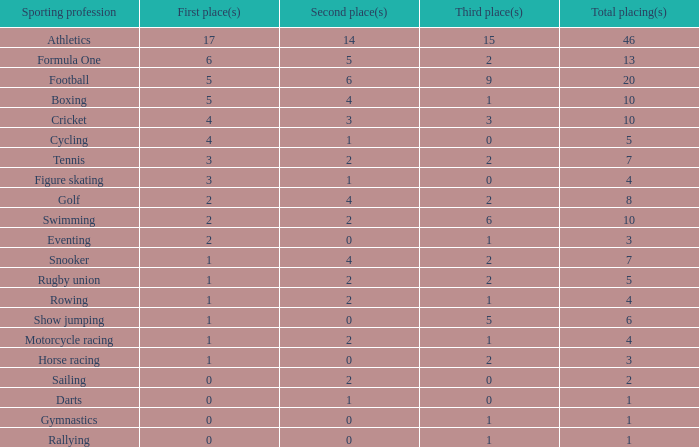How many runner-up performances does snooker have? 4.0. 